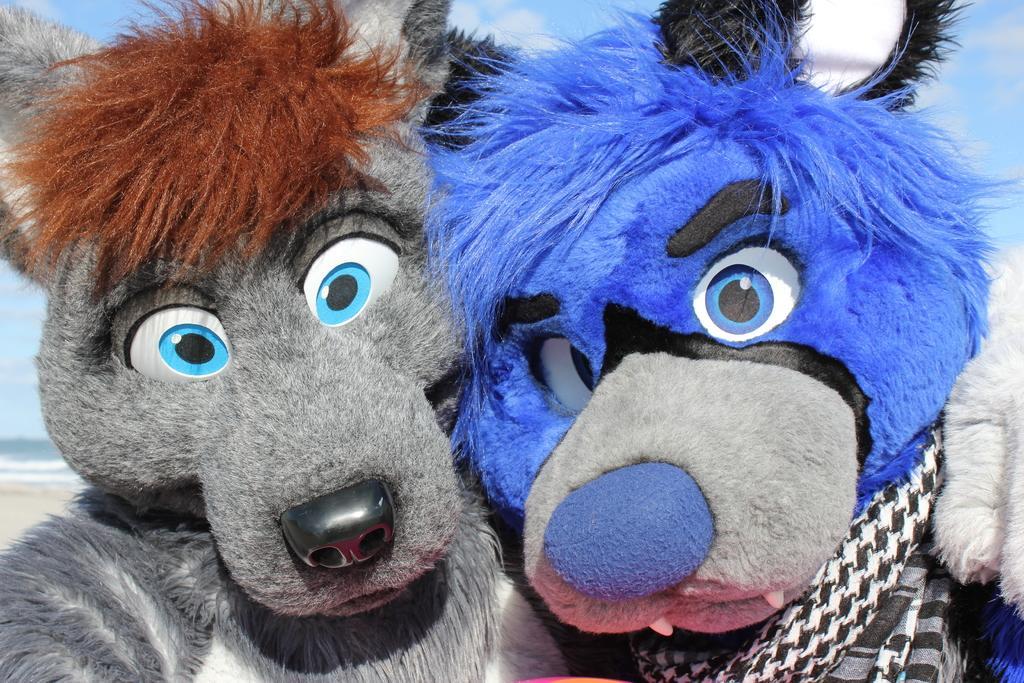Can you describe this image briefly? In this image, there are two toys with different colors. In these two one of them is blue and another one is hash. 